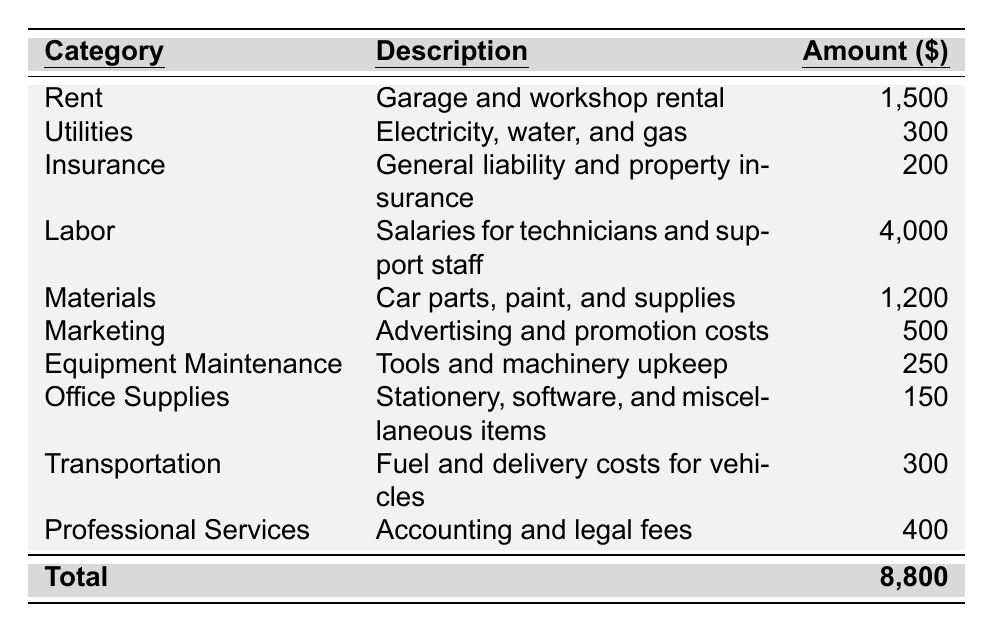What is the total monthly expense for the business? The table shows a row labeled "Total" at the bottom. The corresponding amount listed there is 8,800, which represents the total monthly expenses for the specialty car restoration business.
Answer: 8,800 What is the amount spent on Labor? The Labor category is listed in the table, and its corresponding amount is 4,000. This indicates that the business allocates 4,000 for salaries for technicians and support staff every month.
Answer: 4,000 Is the expense for Utilities greater than the expense for Office Supplies? The Utilities expense is 300, and the Office Supplies expense is 150. Since 300 is greater than 150, the expense for Utilities is indeed greater than that for Office Supplies.
Answer: Yes How much more does the business spend on Materials than on Insurance? The Materials expense is 1,200 and the Insurance expense is 200. To find the difference, subtract the Insurance expense from the Materials expense: 1,200 - 200 = 1,000. Therefore, the business spends 1,000 more on Materials than on Insurance.
Answer: 1,000 What percentage of the total expenses is spent on Marketing? The Marketing expense is 500. To find the percentage of total expenses that this represents, divide the Marketing expense by the total expenses and multiply by 100: (500 / 8,800) * 100 ≈ 5.68%. Therefore, approximately 5.68% of the total monthly expenses are spent on Marketing.
Answer: 5.68% Which category has the highest expense? The category with the highest expense can be found by comparing all listed amounts. Labor is 4,000, which is greater than any other category, thus making it the highest expense category.
Answer: Labor How much do the business's expenses on Equipment Maintenance and Transportation combined equal? The Equipment Maintenance expense is 250, and the Transportation expense is 300. To find the total for both categories, sum these amounts: 250 + 300 = 550. Therefore, the combined total expenses for Equipment Maintenance and Transportation are 550.
Answer: 550 Are the combined expenses for Rent and Insurance greater than the combined expenses for Utilities and Office Supplies? Rent is 1,500 and Insurance is 200, which makes their combined total 1,500 + 200 = 1,700. The combined total for Utilities (300) and Office Supplies (150) is 300 + 150 = 450. Since 1,700 is greater than 450, the combined expenses for Rent and Insurance are indeed greater.
Answer: Yes How much does the business spend on Professional Services relative to the sum of Marketing and Equipment Maintenance? Professional Services expense is 400. Marketing expense is 500 and Equipment Maintenance is 250, summing them gives 500 + 250 = 750. To compare, 400 is less than 750. Therefore, the business spends less on Professional Services than the combined Marketing and Equipment Maintenance expenses.
Answer: Less What is the average expense across all categories? To find the average, sum all the expenses (1,500 + 300 + 200 + 4,000 + 1,200 + 500 + 250 + 150 + 300 + 400 = 8,800) and divide by the number of categories (10). So, 8,800 / 10 = 880. The average monthly expense across all categories is 880.
Answer: 880 